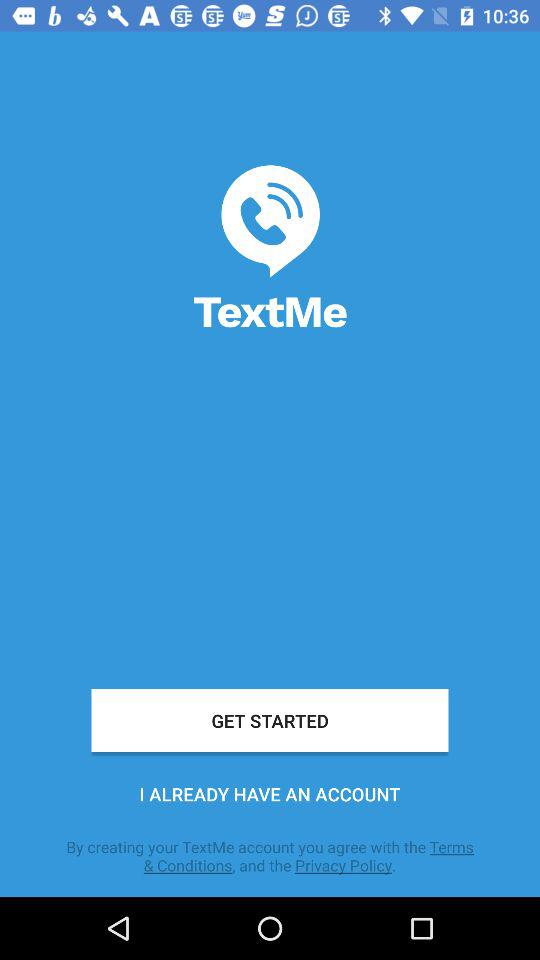What is the app's title?
Answer the question using a single word or phrase. The app's title is "TextMe." 